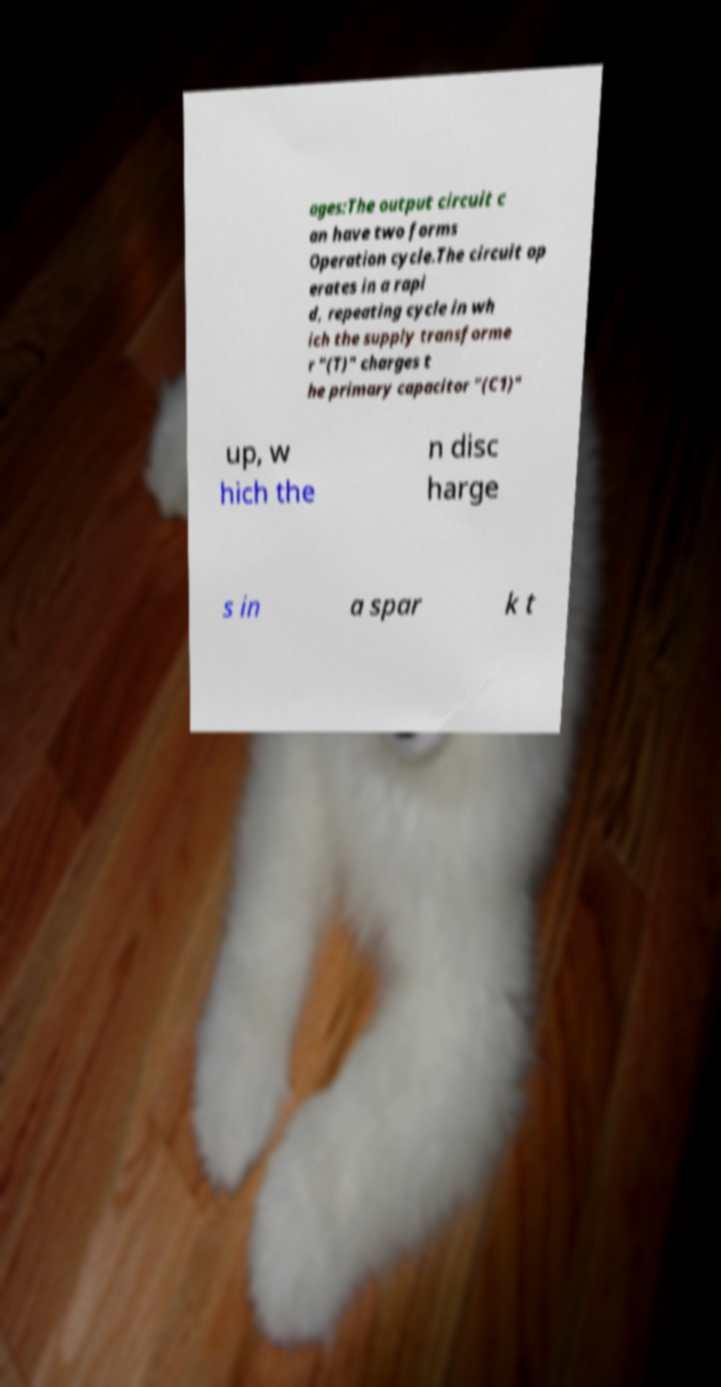Can you accurately transcribe the text from the provided image for me? ages:The output circuit c an have two forms Operation cycle.The circuit op erates in a rapi d, repeating cycle in wh ich the supply transforme r "(T)" charges t he primary capacitor "(C1)" up, w hich the n disc harge s in a spar k t 